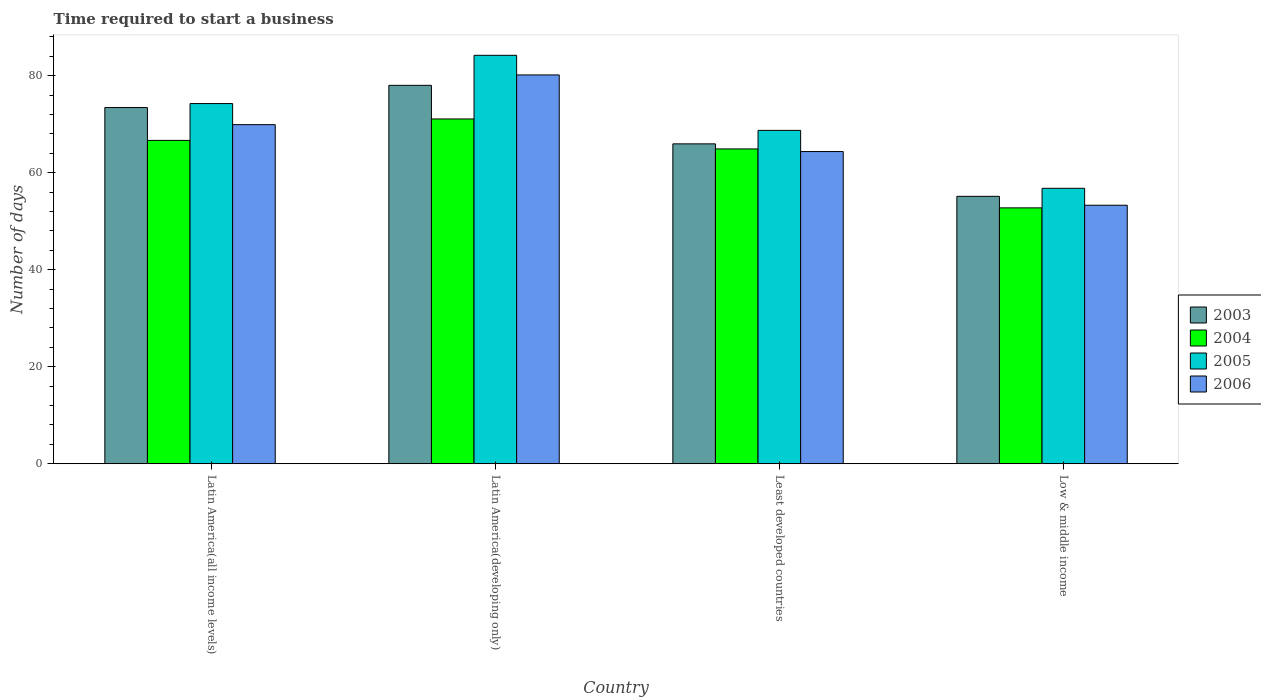Are the number of bars per tick equal to the number of legend labels?
Provide a succinct answer. Yes. How many bars are there on the 1st tick from the left?
Make the answer very short. 4. What is the label of the 3rd group of bars from the left?
Provide a succinct answer. Least developed countries. In how many cases, is the number of bars for a given country not equal to the number of legend labels?
Your response must be concise. 0. What is the number of days required to start a business in 2003 in Least developed countries?
Give a very brief answer. 65.94. Across all countries, what is the maximum number of days required to start a business in 2006?
Offer a terse response. 80.14. Across all countries, what is the minimum number of days required to start a business in 2004?
Offer a very short reply. 52.74. In which country was the number of days required to start a business in 2005 maximum?
Offer a very short reply. Latin America(developing only). What is the total number of days required to start a business in 2005 in the graph?
Keep it short and to the point. 283.92. What is the difference between the number of days required to start a business in 2004 in Latin America(all income levels) and that in Latin America(developing only)?
Provide a succinct answer. -4.42. What is the difference between the number of days required to start a business in 2004 in Latin America(developing only) and the number of days required to start a business in 2005 in Least developed countries?
Provide a succinct answer. 2.35. What is the average number of days required to start a business in 2005 per country?
Ensure brevity in your answer.  70.98. What is the difference between the number of days required to start a business of/in 2004 and number of days required to start a business of/in 2006 in Latin America(developing only)?
Your answer should be compact. -9.08. In how many countries, is the number of days required to start a business in 2006 greater than 36 days?
Your response must be concise. 4. What is the ratio of the number of days required to start a business in 2006 in Least developed countries to that in Low & middle income?
Ensure brevity in your answer.  1.21. What is the difference between the highest and the second highest number of days required to start a business in 2004?
Your answer should be compact. -1.76. What is the difference between the highest and the lowest number of days required to start a business in 2006?
Provide a short and direct response. 26.86. Is the sum of the number of days required to start a business in 2005 in Latin America(developing only) and Least developed countries greater than the maximum number of days required to start a business in 2006 across all countries?
Provide a succinct answer. Yes. Is it the case that in every country, the sum of the number of days required to start a business in 2005 and number of days required to start a business in 2004 is greater than the sum of number of days required to start a business in 2003 and number of days required to start a business in 2006?
Keep it short and to the point. No. What does the 2nd bar from the left in Latin America(developing only) represents?
Your answer should be compact. 2004. Are all the bars in the graph horizontal?
Make the answer very short. No. Are the values on the major ticks of Y-axis written in scientific E-notation?
Your answer should be very brief. No. Does the graph contain any zero values?
Offer a very short reply. No. What is the title of the graph?
Your answer should be very brief. Time required to start a business. Does "1965" appear as one of the legend labels in the graph?
Provide a short and direct response. No. What is the label or title of the Y-axis?
Make the answer very short. Number of days. What is the Number of days in 2003 in Latin America(all income levels)?
Offer a very short reply. 73.42. What is the Number of days of 2004 in Latin America(all income levels)?
Give a very brief answer. 66.65. What is the Number of days in 2005 in Latin America(all income levels)?
Ensure brevity in your answer.  74.24. What is the Number of days of 2006 in Latin America(all income levels)?
Offer a very short reply. 69.9. What is the Number of days in 2003 in Latin America(developing only)?
Give a very brief answer. 78. What is the Number of days of 2004 in Latin America(developing only)?
Your response must be concise. 71.07. What is the Number of days in 2005 in Latin America(developing only)?
Keep it short and to the point. 84.19. What is the Number of days of 2006 in Latin America(developing only)?
Your answer should be very brief. 80.14. What is the Number of days in 2003 in Least developed countries?
Your answer should be compact. 65.94. What is the Number of days of 2004 in Least developed countries?
Your response must be concise. 64.89. What is the Number of days of 2005 in Least developed countries?
Your answer should be compact. 68.71. What is the Number of days of 2006 in Least developed countries?
Your answer should be very brief. 64.35. What is the Number of days of 2003 in Low & middle income?
Offer a very short reply. 55.12. What is the Number of days in 2004 in Low & middle income?
Provide a short and direct response. 52.74. What is the Number of days in 2005 in Low & middle income?
Your answer should be very brief. 56.77. What is the Number of days of 2006 in Low & middle income?
Provide a short and direct response. 53.28. Across all countries, what is the maximum Number of days of 2003?
Your answer should be very brief. 78. Across all countries, what is the maximum Number of days in 2004?
Your answer should be very brief. 71.07. Across all countries, what is the maximum Number of days in 2005?
Offer a terse response. 84.19. Across all countries, what is the maximum Number of days in 2006?
Offer a very short reply. 80.14. Across all countries, what is the minimum Number of days of 2003?
Give a very brief answer. 55.12. Across all countries, what is the minimum Number of days in 2004?
Make the answer very short. 52.74. Across all countries, what is the minimum Number of days of 2005?
Provide a succinct answer. 56.77. Across all countries, what is the minimum Number of days in 2006?
Provide a succinct answer. 53.28. What is the total Number of days in 2003 in the graph?
Offer a terse response. 272.48. What is the total Number of days in 2004 in the graph?
Provide a short and direct response. 255.35. What is the total Number of days of 2005 in the graph?
Your answer should be very brief. 283.92. What is the total Number of days in 2006 in the graph?
Your answer should be very brief. 267.67. What is the difference between the Number of days of 2003 in Latin America(all income levels) and that in Latin America(developing only)?
Your answer should be compact. -4.58. What is the difference between the Number of days of 2004 in Latin America(all income levels) and that in Latin America(developing only)?
Provide a short and direct response. -4.42. What is the difference between the Number of days in 2005 in Latin America(all income levels) and that in Latin America(developing only)?
Give a very brief answer. -9.95. What is the difference between the Number of days of 2006 in Latin America(all income levels) and that in Latin America(developing only)?
Your answer should be very brief. -10.25. What is the difference between the Number of days in 2003 in Latin America(all income levels) and that in Least developed countries?
Your answer should be very brief. 7.48. What is the difference between the Number of days in 2004 in Latin America(all income levels) and that in Least developed countries?
Make the answer very short. 1.76. What is the difference between the Number of days in 2005 in Latin America(all income levels) and that in Least developed countries?
Provide a succinct answer. 5.53. What is the difference between the Number of days of 2006 in Latin America(all income levels) and that in Least developed countries?
Give a very brief answer. 5.55. What is the difference between the Number of days of 2003 in Latin America(all income levels) and that in Low & middle income?
Offer a terse response. 18.3. What is the difference between the Number of days of 2004 in Latin America(all income levels) and that in Low & middle income?
Provide a short and direct response. 13.91. What is the difference between the Number of days in 2005 in Latin America(all income levels) and that in Low & middle income?
Provide a short and direct response. 17.47. What is the difference between the Number of days in 2006 in Latin America(all income levels) and that in Low & middle income?
Provide a succinct answer. 16.61. What is the difference between the Number of days of 2003 in Latin America(developing only) and that in Least developed countries?
Ensure brevity in your answer.  12.06. What is the difference between the Number of days of 2004 in Latin America(developing only) and that in Least developed countries?
Ensure brevity in your answer.  6.17. What is the difference between the Number of days in 2005 in Latin America(developing only) and that in Least developed countries?
Give a very brief answer. 15.48. What is the difference between the Number of days in 2006 in Latin America(developing only) and that in Least developed countries?
Give a very brief answer. 15.79. What is the difference between the Number of days of 2003 in Latin America(developing only) and that in Low & middle income?
Your answer should be compact. 22.88. What is the difference between the Number of days of 2004 in Latin America(developing only) and that in Low & middle income?
Make the answer very short. 18.32. What is the difference between the Number of days of 2005 in Latin America(developing only) and that in Low & middle income?
Your answer should be compact. 27.42. What is the difference between the Number of days in 2006 in Latin America(developing only) and that in Low & middle income?
Your answer should be very brief. 26.86. What is the difference between the Number of days in 2003 in Least developed countries and that in Low & middle income?
Offer a very short reply. 10.82. What is the difference between the Number of days in 2004 in Least developed countries and that in Low & middle income?
Provide a succinct answer. 12.15. What is the difference between the Number of days of 2005 in Least developed countries and that in Low & middle income?
Make the answer very short. 11.94. What is the difference between the Number of days in 2006 in Least developed countries and that in Low & middle income?
Keep it short and to the point. 11.07. What is the difference between the Number of days in 2003 in Latin America(all income levels) and the Number of days in 2004 in Latin America(developing only)?
Give a very brief answer. 2.35. What is the difference between the Number of days of 2003 in Latin America(all income levels) and the Number of days of 2005 in Latin America(developing only)?
Your response must be concise. -10.77. What is the difference between the Number of days in 2003 in Latin America(all income levels) and the Number of days in 2006 in Latin America(developing only)?
Offer a very short reply. -6.72. What is the difference between the Number of days of 2004 in Latin America(all income levels) and the Number of days of 2005 in Latin America(developing only)?
Provide a short and direct response. -17.54. What is the difference between the Number of days in 2004 in Latin America(all income levels) and the Number of days in 2006 in Latin America(developing only)?
Your response must be concise. -13.49. What is the difference between the Number of days of 2005 in Latin America(all income levels) and the Number of days of 2006 in Latin America(developing only)?
Offer a very short reply. -5.9. What is the difference between the Number of days of 2003 in Latin America(all income levels) and the Number of days of 2004 in Least developed countries?
Ensure brevity in your answer.  8.53. What is the difference between the Number of days of 2003 in Latin America(all income levels) and the Number of days of 2005 in Least developed countries?
Offer a very short reply. 4.71. What is the difference between the Number of days of 2003 in Latin America(all income levels) and the Number of days of 2006 in Least developed countries?
Keep it short and to the point. 9.07. What is the difference between the Number of days in 2004 in Latin America(all income levels) and the Number of days in 2005 in Least developed countries?
Make the answer very short. -2.06. What is the difference between the Number of days of 2004 in Latin America(all income levels) and the Number of days of 2006 in Least developed countries?
Offer a terse response. 2.3. What is the difference between the Number of days in 2005 in Latin America(all income levels) and the Number of days in 2006 in Least developed countries?
Your answer should be compact. 9.89. What is the difference between the Number of days in 2003 in Latin America(all income levels) and the Number of days in 2004 in Low & middle income?
Offer a very short reply. 20.68. What is the difference between the Number of days of 2003 in Latin America(all income levels) and the Number of days of 2005 in Low & middle income?
Your answer should be compact. 16.65. What is the difference between the Number of days in 2003 in Latin America(all income levels) and the Number of days in 2006 in Low & middle income?
Provide a succinct answer. 20.14. What is the difference between the Number of days of 2004 in Latin America(all income levels) and the Number of days of 2005 in Low & middle income?
Your answer should be compact. 9.88. What is the difference between the Number of days in 2004 in Latin America(all income levels) and the Number of days in 2006 in Low & middle income?
Offer a terse response. 13.37. What is the difference between the Number of days in 2005 in Latin America(all income levels) and the Number of days in 2006 in Low & middle income?
Ensure brevity in your answer.  20.96. What is the difference between the Number of days in 2003 in Latin America(developing only) and the Number of days in 2004 in Least developed countries?
Provide a succinct answer. 13.11. What is the difference between the Number of days of 2003 in Latin America(developing only) and the Number of days of 2005 in Least developed countries?
Give a very brief answer. 9.29. What is the difference between the Number of days of 2003 in Latin America(developing only) and the Number of days of 2006 in Least developed countries?
Make the answer very short. 13.65. What is the difference between the Number of days of 2004 in Latin America(developing only) and the Number of days of 2005 in Least developed countries?
Offer a very short reply. 2.35. What is the difference between the Number of days of 2004 in Latin America(developing only) and the Number of days of 2006 in Least developed countries?
Provide a succinct answer. 6.72. What is the difference between the Number of days of 2005 in Latin America(developing only) and the Number of days of 2006 in Least developed countries?
Give a very brief answer. 19.84. What is the difference between the Number of days of 2003 in Latin America(developing only) and the Number of days of 2004 in Low & middle income?
Provide a succinct answer. 25.26. What is the difference between the Number of days of 2003 in Latin America(developing only) and the Number of days of 2005 in Low & middle income?
Offer a terse response. 21.23. What is the difference between the Number of days of 2003 in Latin America(developing only) and the Number of days of 2006 in Low & middle income?
Offer a very short reply. 24.72. What is the difference between the Number of days in 2004 in Latin America(developing only) and the Number of days in 2005 in Low & middle income?
Keep it short and to the point. 14.29. What is the difference between the Number of days in 2004 in Latin America(developing only) and the Number of days in 2006 in Low & middle income?
Provide a short and direct response. 17.78. What is the difference between the Number of days in 2005 in Latin America(developing only) and the Number of days in 2006 in Low & middle income?
Provide a succinct answer. 30.91. What is the difference between the Number of days in 2003 in Least developed countries and the Number of days in 2004 in Low & middle income?
Provide a short and direct response. 13.19. What is the difference between the Number of days of 2003 in Least developed countries and the Number of days of 2005 in Low & middle income?
Your response must be concise. 9.16. What is the difference between the Number of days of 2003 in Least developed countries and the Number of days of 2006 in Low & middle income?
Your response must be concise. 12.66. What is the difference between the Number of days of 2004 in Least developed countries and the Number of days of 2005 in Low & middle income?
Ensure brevity in your answer.  8.12. What is the difference between the Number of days of 2004 in Least developed countries and the Number of days of 2006 in Low & middle income?
Offer a terse response. 11.61. What is the difference between the Number of days in 2005 in Least developed countries and the Number of days in 2006 in Low & middle income?
Offer a very short reply. 15.43. What is the average Number of days in 2003 per country?
Provide a succinct answer. 68.12. What is the average Number of days in 2004 per country?
Your answer should be very brief. 63.84. What is the average Number of days in 2005 per country?
Your answer should be compact. 70.98. What is the average Number of days in 2006 per country?
Offer a very short reply. 66.92. What is the difference between the Number of days of 2003 and Number of days of 2004 in Latin America(all income levels)?
Ensure brevity in your answer.  6.77. What is the difference between the Number of days in 2003 and Number of days in 2005 in Latin America(all income levels)?
Your answer should be very brief. -0.82. What is the difference between the Number of days in 2003 and Number of days in 2006 in Latin America(all income levels)?
Offer a very short reply. 3.52. What is the difference between the Number of days of 2004 and Number of days of 2005 in Latin America(all income levels)?
Make the answer very short. -7.59. What is the difference between the Number of days in 2004 and Number of days in 2006 in Latin America(all income levels)?
Provide a succinct answer. -3.25. What is the difference between the Number of days of 2005 and Number of days of 2006 in Latin America(all income levels)?
Offer a very short reply. 4.34. What is the difference between the Number of days of 2003 and Number of days of 2004 in Latin America(developing only)?
Your response must be concise. 6.93. What is the difference between the Number of days of 2003 and Number of days of 2005 in Latin America(developing only)?
Provide a short and direct response. -6.19. What is the difference between the Number of days of 2003 and Number of days of 2006 in Latin America(developing only)?
Your response must be concise. -2.14. What is the difference between the Number of days in 2004 and Number of days in 2005 in Latin America(developing only)?
Offer a terse response. -13.12. What is the difference between the Number of days in 2004 and Number of days in 2006 in Latin America(developing only)?
Your answer should be compact. -9.08. What is the difference between the Number of days in 2005 and Number of days in 2006 in Latin America(developing only)?
Ensure brevity in your answer.  4.05. What is the difference between the Number of days of 2003 and Number of days of 2004 in Least developed countries?
Your answer should be compact. 1.05. What is the difference between the Number of days in 2003 and Number of days in 2005 in Least developed countries?
Give a very brief answer. -2.78. What is the difference between the Number of days in 2003 and Number of days in 2006 in Least developed countries?
Ensure brevity in your answer.  1.59. What is the difference between the Number of days of 2004 and Number of days of 2005 in Least developed countries?
Offer a terse response. -3.82. What is the difference between the Number of days of 2004 and Number of days of 2006 in Least developed countries?
Make the answer very short. 0.54. What is the difference between the Number of days of 2005 and Number of days of 2006 in Least developed countries?
Your answer should be very brief. 4.37. What is the difference between the Number of days of 2003 and Number of days of 2004 in Low & middle income?
Give a very brief answer. 2.38. What is the difference between the Number of days in 2003 and Number of days in 2005 in Low & middle income?
Ensure brevity in your answer.  -1.65. What is the difference between the Number of days in 2003 and Number of days in 2006 in Low & middle income?
Offer a very short reply. 1.84. What is the difference between the Number of days in 2004 and Number of days in 2005 in Low & middle income?
Provide a short and direct response. -4.03. What is the difference between the Number of days of 2004 and Number of days of 2006 in Low & middle income?
Your answer should be very brief. -0.54. What is the difference between the Number of days in 2005 and Number of days in 2006 in Low & middle income?
Keep it short and to the point. 3.49. What is the ratio of the Number of days of 2003 in Latin America(all income levels) to that in Latin America(developing only)?
Make the answer very short. 0.94. What is the ratio of the Number of days of 2004 in Latin America(all income levels) to that in Latin America(developing only)?
Provide a succinct answer. 0.94. What is the ratio of the Number of days of 2005 in Latin America(all income levels) to that in Latin America(developing only)?
Your answer should be very brief. 0.88. What is the ratio of the Number of days of 2006 in Latin America(all income levels) to that in Latin America(developing only)?
Provide a short and direct response. 0.87. What is the ratio of the Number of days of 2003 in Latin America(all income levels) to that in Least developed countries?
Your answer should be compact. 1.11. What is the ratio of the Number of days of 2004 in Latin America(all income levels) to that in Least developed countries?
Your answer should be compact. 1.03. What is the ratio of the Number of days of 2005 in Latin America(all income levels) to that in Least developed countries?
Give a very brief answer. 1.08. What is the ratio of the Number of days in 2006 in Latin America(all income levels) to that in Least developed countries?
Provide a short and direct response. 1.09. What is the ratio of the Number of days of 2003 in Latin America(all income levels) to that in Low & middle income?
Provide a short and direct response. 1.33. What is the ratio of the Number of days in 2004 in Latin America(all income levels) to that in Low & middle income?
Provide a short and direct response. 1.26. What is the ratio of the Number of days of 2005 in Latin America(all income levels) to that in Low & middle income?
Give a very brief answer. 1.31. What is the ratio of the Number of days in 2006 in Latin America(all income levels) to that in Low & middle income?
Your answer should be compact. 1.31. What is the ratio of the Number of days of 2003 in Latin America(developing only) to that in Least developed countries?
Ensure brevity in your answer.  1.18. What is the ratio of the Number of days of 2004 in Latin America(developing only) to that in Least developed countries?
Your answer should be compact. 1.1. What is the ratio of the Number of days of 2005 in Latin America(developing only) to that in Least developed countries?
Provide a succinct answer. 1.23. What is the ratio of the Number of days of 2006 in Latin America(developing only) to that in Least developed countries?
Give a very brief answer. 1.25. What is the ratio of the Number of days in 2003 in Latin America(developing only) to that in Low & middle income?
Ensure brevity in your answer.  1.42. What is the ratio of the Number of days of 2004 in Latin America(developing only) to that in Low & middle income?
Provide a succinct answer. 1.35. What is the ratio of the Number of days in 2005 in Latin America(developing only) to that in Low & middle income?
Your response must be concise. 1.48. What is the ratio of the Number of days of 2006 in Latin America(developing only) to that in Low & middle income?
Provide a succinct answer. 1.5. What is the ratio of the Number of days in 2003 in Least developed countries to that in Low & middle income?
Offer a terse response. 1.2. What is the ratio of the Number of days in 2004 in Least developed countries to that in Low & middle income?
Make the answer very short. 1.23. What is the ratio of the Number of days of 2005 in Least developed countries to that in Low & middle income?
Provide a short and direct response. 1.21. What is the ratio of the Number of days in 2006 in Least developed countries to that in Low & middle income?
Make the answer very short. 1.21. What is the difference between the highest and the second highest Number of days of 2003?
Make the answer very short. 4.58. What is the difference between the highest and the second highest Number of days of 2004?
Your response must be concise. 4.42. What is the difference between the highest and the second highest Number of days in 2005?
Your answer should be very brief. 9.95. What is the difference between the highest and the second highest Number of days of 2006?
Make the answer very short. 10.25. What is the difference between the highest and the lowest Number of days in 2003?
Keep it short and to the point. 22.88. What is the difference between the highest and the lowest Number of days in 2004?
Give a very brief answer. 18.32. What is the difference between the highest and the lowest Number of days of 2005?
Give a very brief answer. 27.42. What is the difference between the highest and the lowest Number of days in 2006?
Ensure brevity in your answer.  26.86. 